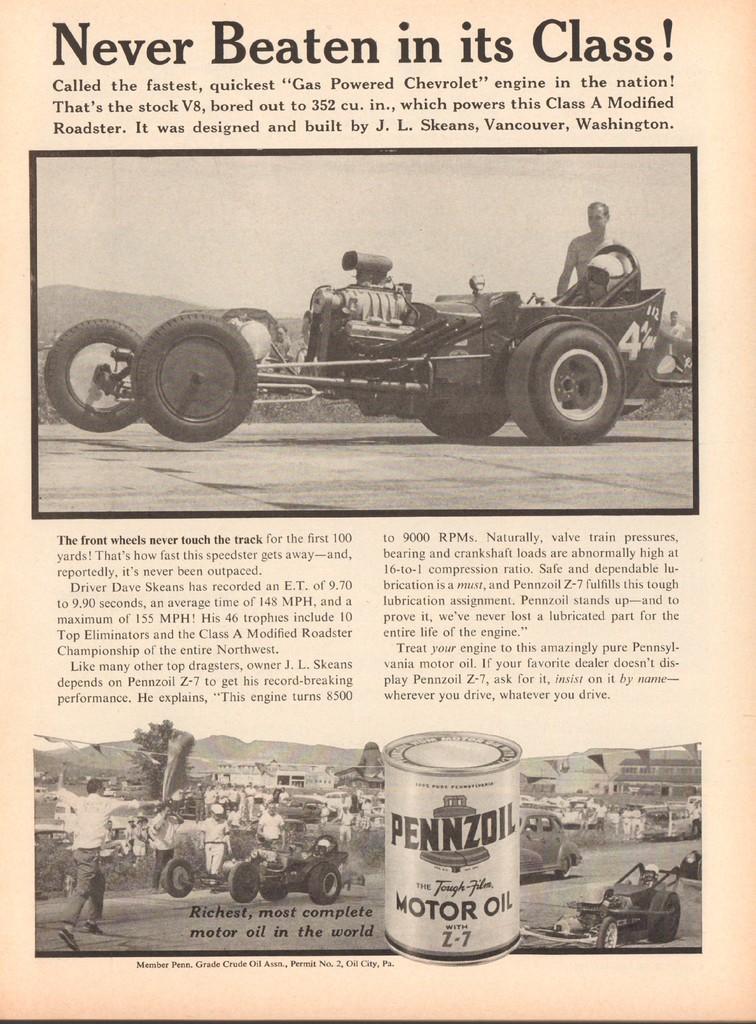How would you summarize this image in a sentence or two? Here we can see two pictures and some text written on paper. In the first picture we can see a vehicle and a man and in the second picture we can see vehicles on the road,buildings and a person and we can also see a tin here. 